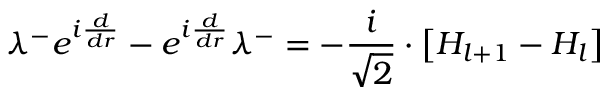Convert formula to latex. <formula><loc_0><loc_0><loc_500><loc_500>\lambda ^ { - } e ^ { i \frac { d } { d r } } - e ^ { i \frac { d } { d r } } \lambda ^ { - } = - \frac { i } { \sqrt { 2 } } \cdot \left [ H _ { l + 1 } - H _ { l } \right ]</formula> 